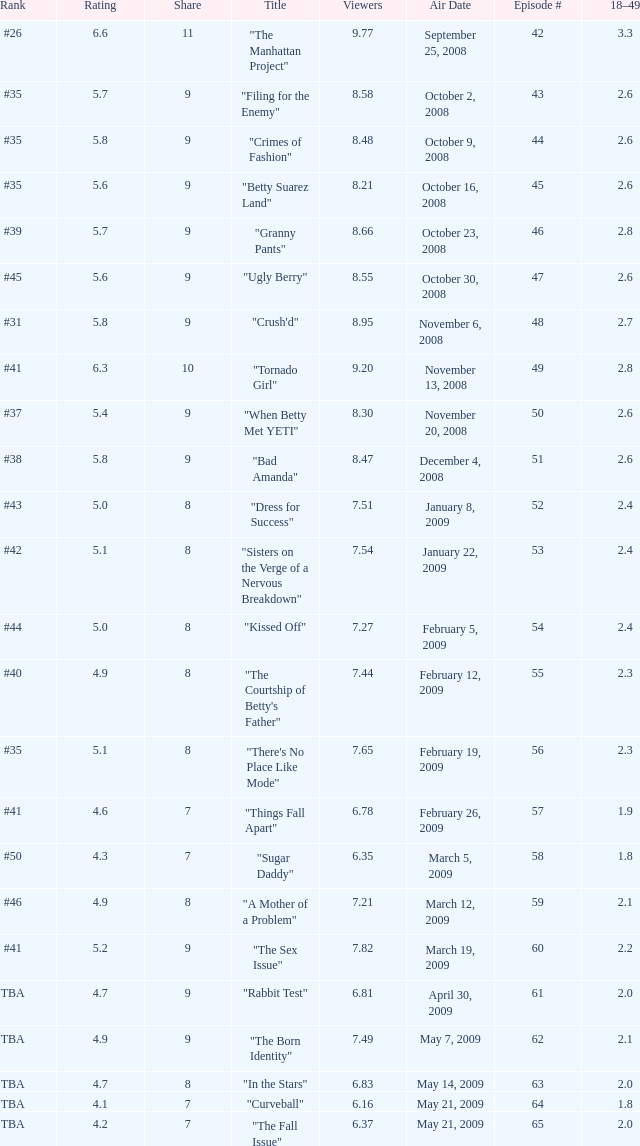What is the average Episode # with a share of 9, and #35 is rank and less than 8.21 viewers? None. Can you give me this table as a dict? {'header': ['Rank', 'Rating', 'Share', 'Title', 'Viewers', 'Air Date', 'Episode #', '18–49'], 'rows': [['#26', '6.6', '11', '"The Manhattan Project"', '9.77', 'September 25, 2008', '42', '3.3'], ['#35', '5.7', '9', '"Filing for the Enemy"', '8.58', 'October 2, 2008', '43', '2.6'], ['#35', '5.8', '9', '"Crimes of Fashion"', '8.48', 'October 9, 2008', '44', '2.6'], ['#35', '5.6', '9', '"Betty Suarez Land"', '8.21', 'October 16, 2008', '45', '2.6'], ['#39', '5.7', '9', '"Granny Pants"', '8.66', 'October 23, 2008', '46', '2.8'], ['#45', '5.6', '9', '"Ugly Berry"', '8.55', 'October 30, 2008', '47', '2.6'], ['#31', '5.8', '9', '"Crush\'d"', '8.95', 'November 6, 2008', '48', '2.7'], ['#41', '6.3', '10', '"Tornado Girl"', '9.20', 'November 13, 2008', '49', '2.8'], ['#37', '5.4', '9', '"When Betty Met YETI"', '8.30', 'November 20, 2008', '50', '2.6'], ['#38', '5.8', '9', '"Bad Amanda"', '8.47', 'December 4, 2008', '51', '2.6'], ['#43', '5.0', '8', '"Dress for Success"', '7.51', 'January 8, 2009', '52', '2.4'], ['#42', '5.1', '8', '"Sisters on the Verge of a Nervous Breakdown"', '7.54', 'January 22, 2009', '53', '2.4'], ['#44', '5.0', '8', '"Kissed Off"', '7.27', 'February 5, 2009', '54', '2.4'], ['#40', '4.9', '8', '"The Courtship of Betty\'s Father"', '7.44', 'February 12, 2009', '55', '2.3'], ['#35', '5.1', '8', '"There\'s No Place Like Mode"', '7.65', 'February 19, 2009', '56', '2.3'], ['#41', '4.6', '7', '"Things Fall Apart"', '6.78', 'February 26, 2009', '57', '1.9'], ['#50', '4.3', '7', '"Sugar Daddy"', '6.35', 'March 5, 2009', '58', '1.8'], ['#46', '4.9', '8', '"A Mother of a Problem"', '7.21', 'March 12, 2009', '59', '2.1'], ['#41', '5.2', '9', '"The Sex Issue"', '7.82', 'March 19, 2009', '60', '2.2'], ['TBA', '4.7', '9', '"Rabbit Test"', '6.81', 'April 30, 2009', '61', '2.0'], ['TBA', '4.9', '9', '"The Born Identity"', '7.49', 'May 7, 2009', '62', '2.1'], ['TBA', '4.7', '8', '"In the Stars"', '6.83', 'May 14, 2009', '63', '2.0'], ['TBA', '4.1', '7', '"Curveball"', '6.16', 'May 21, 2009', '64', '1.8'], ['TBA', '4.2', '7', '"The Fall Issue"', '6.37', 'May 21, 2009', '65', '2.0']]} 